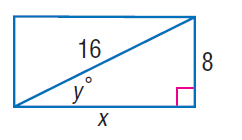Answer the mathemtical geometry problem and directly provide the correct option letter.
Question: Find y.
Choices: A: 30 B: 60 C: 90 D: 120 A 